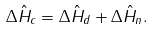<formula> <loc_0><loc_0><loc_500><loc_500>\Delta \hat { H } _ { c } = \Delta \hat { H } _ { d } + \Delta \hat { H } _ { n } .</formula> 